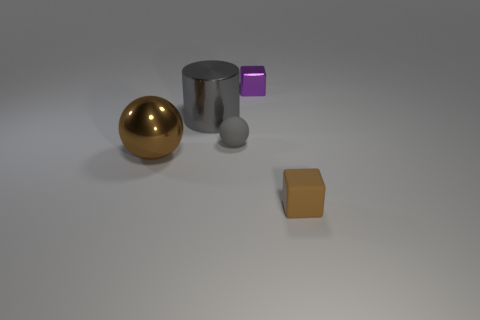What is the approximate size ratio between the golden ball and the gray cylinder? While precise measurements can't be determined from the image, the golden ball looks to be roughly the same height as the gray cylinder but smaller in diameter, suggesting a size ratio where the cylinder is taller and wider compared to the diameter of the ball. 